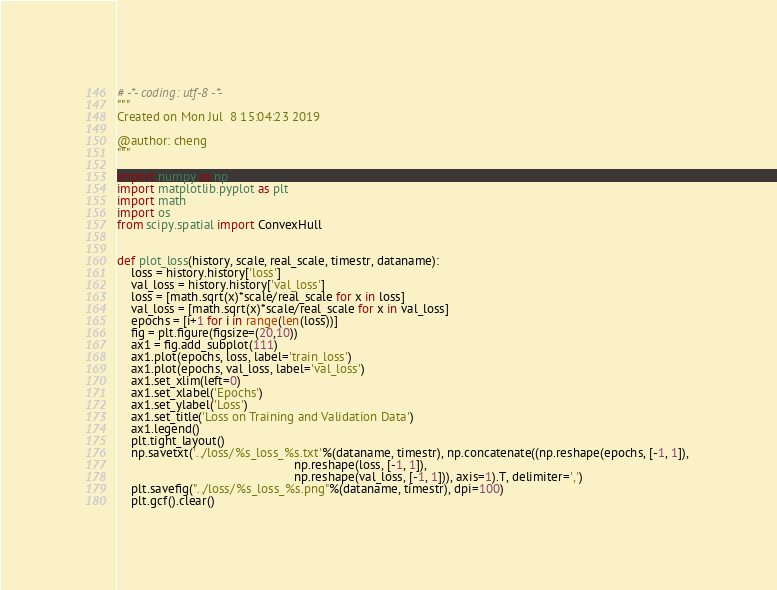<code> <loc_0><loc_0><loc_500><loc_500><_Python_># -*- coding: utf-8 -*-
"""
Created on Mon Jul  8 15:04:23 2019

@author: cheng
"""

import numpy as np
import matplotlib.pyplot as plt
import math
import os
from scipy.spatial import ConvexHull
    
    
def plot_loss(history, scale, real_scale, timestr, dataname):
    loss = history.history['loss']   
    val_loss = history.history['val_loss']
    loss = [math.sqrt(x)*scale/real_scale for x in loss]
    val_loss = [math.sqrt(x)*scale/real_scale for x in val_loss]
    epochs = [i+1 for i in range(len(loss))]
    fig = plt.figure(figsize=(20,10))
    ax1 = fig.add_subplot(111)
    ax1.plot(epochs, loss, label='train_loss')
    ax1.plot(epochs, val_loss, label='val_loss')
    ax1.set_xlim(left=0)
    ax1.set_xlabel('Epochs')
    ax1.set_ylabel('Loss')
    ax1.set_title('Loss on Training and Validation Data')
    ax1.legend()
    plt.tight_layout()
    np.savetxt('../loss/%s_loss_%s.txt'%(dataname, timestr), np.concatenate((np.reshape(epochs, [-1, 1]), 
                                                   np.reshape(loss, [-1, 1]), 
                                                   np.reshape(val_loss, [-1, 1])), axis=1).T, delimiter=',')
    plt.savefig("../loss/%s_loss_%s.png"%(dataname, timestr), dpi=100)
    plt.gcf().clear()</code> 